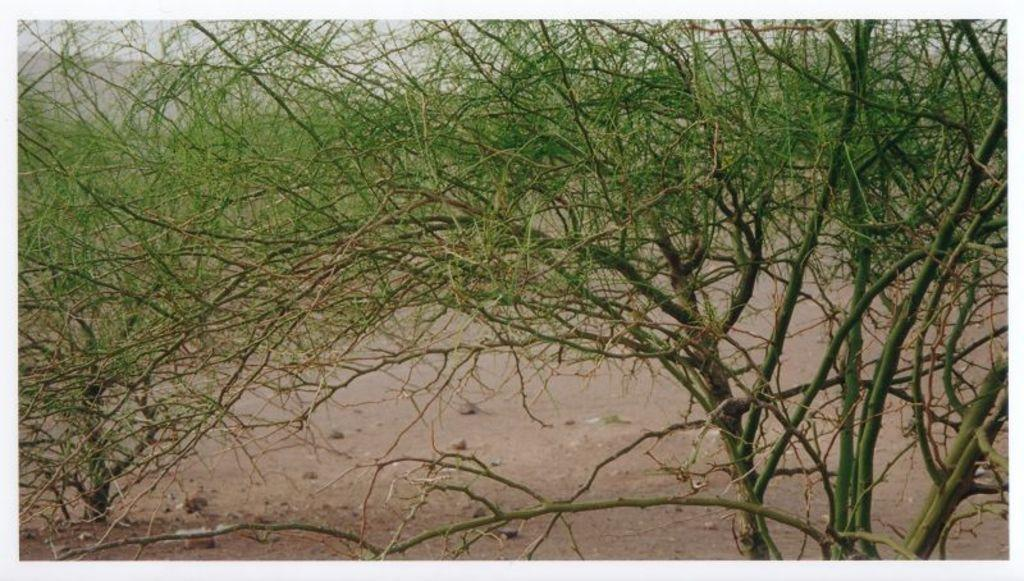Where was the image taken? The image was taken outdoors. What can be seen at the bottom of the image? There is a ground visible at the bottom of the image. What type of natural environment is present in the image? There are many trees in the image. What type of nose can be seen on the airplane in the image? There is no airplane present in the image, so there is no nose to observe. 